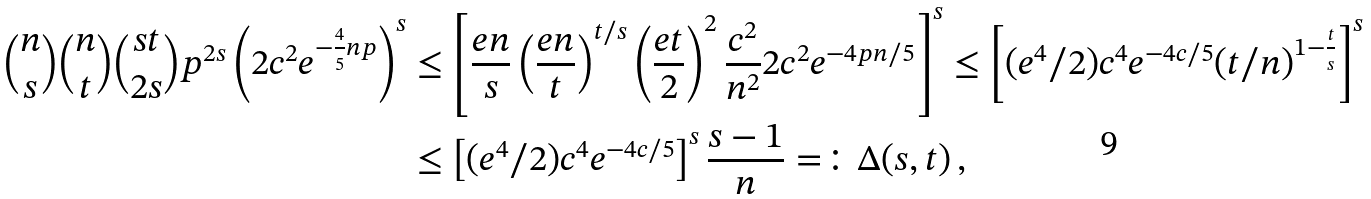<formula> <loc_0><loc_0><loc_500><loc_500>\binom { n } s \binom { n } t \binom { s t } { 2 s } p ^ { 2 s } \left ( 2 c ^ { 2 } e ^ { - \frac { 4 } { 5 } n p } \right ) ^ { s } & \leq \left [ \frac { e n } { s } \left ( \frac { e n } t \right ) ^ { t / s } \left ( \frac { e t } 2 \right ) ^ { 2 } \frac { c ^ { 2 } } { n ^ { 2 } } 2 c ^ { 2 } e ^ { - 4 p n / 5 } \right ] ^ { s } \leq \left [ ( e ^ { 4 } / 2 ) c ^ { 4 } e ^ { - 4 c / 5 } ( t / n ) ^ { 1 - \frac { t } s } \right ] ^ { s } \\ & \leq \left [ ( e ^ { 4 } / 2 ) c ^ { 4 } e ^ { - 4 c / 5 } \right ] ^ { s } \frac { s - 1 } n = \colon \Delta ( s , t ) \, ,</formula> 